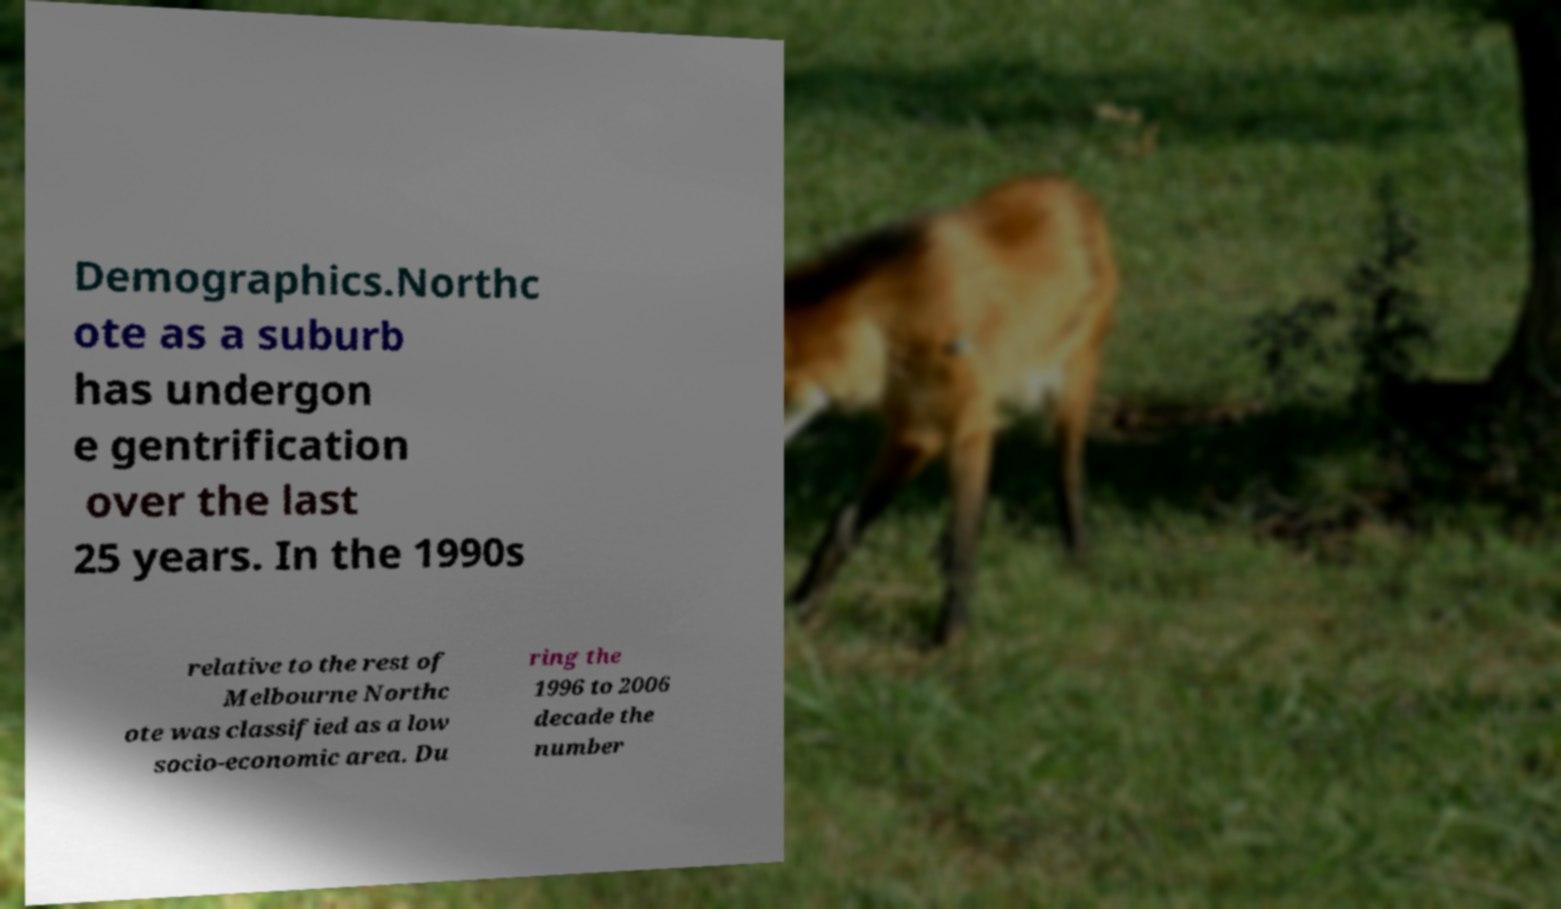Can you read and provide the text displayed in the image?This photo seems to have some interesting text. Can you extract and type it out for me? Demographics.Northc ote as a suburb has undergon e gentrification over the last 25 years. In the 1990s relative to the rest of Melbourne Northc ote was classified as a low socio-economic area. Du ring the 1996 to 2006 decade the number 